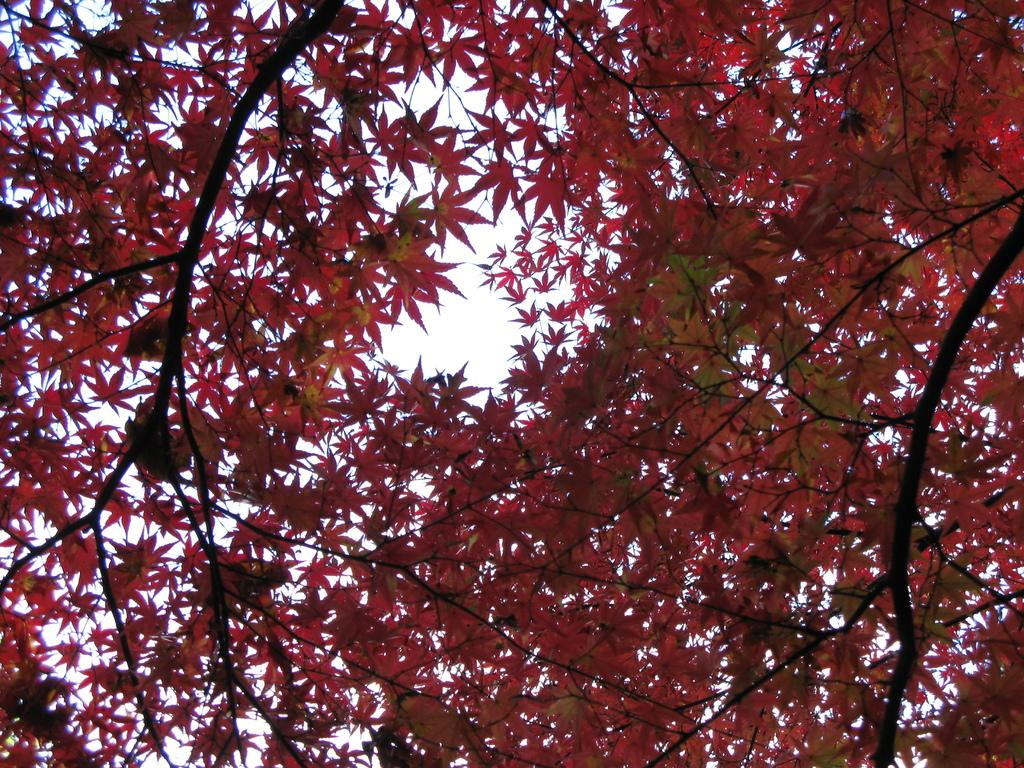What type of tree is present in the image? There is a tree with orange color leaves in the image. What can be seen in the background of the image? The sky is visible in the background of the image. How many cows are grazing in the wilderness in the image? There are no cows or wilderness present in the image; it features a tree with orange leaves and a visible sky. 